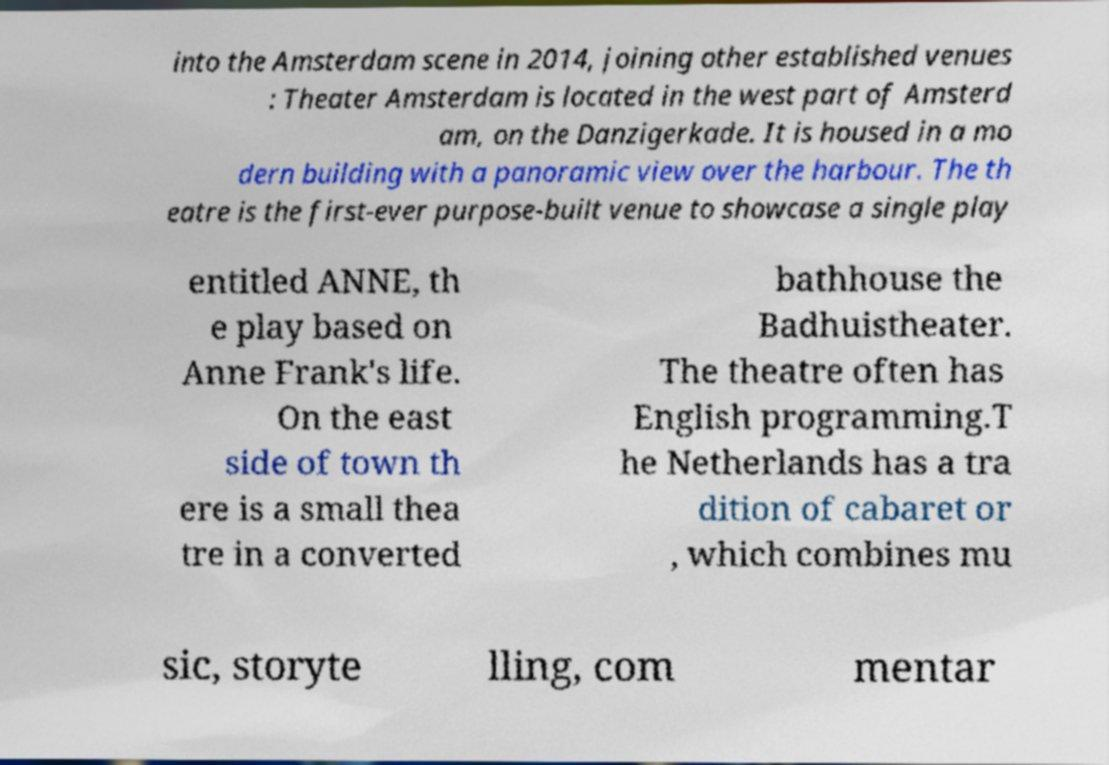Can you accurately transcribe the text from the provided image for me? into the Amsterdam scene in 2014, joining other established venues : Theater Amsterdam is located in the west part of Amsterd am, on the Danzigerkade. It is housed in a mo dern building with a panoramic view over the harbour. The th eatre is the first-ever purpose-built venue to showcase a single play entitled ANNE, th e play based on Anne Frank's life. On the east side of town th ere is a small thea tre in a converted bathhouse the Badhuistheater. The theatre often has English programming.T he Netherlands has a tra dition of cabaret or , which combines mu sic, storyte lling, com mentar 